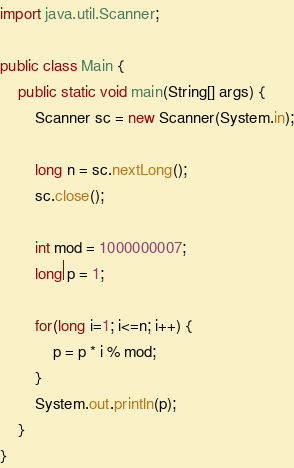<code> <loc_0><loc_0><loc_500><loc_500><_Java_>import java.util.Scanner;

public class Main {
    public static void main(String[] args) {
        Scanner sc = new Scanner(System.in);

        long n = sc.nextLong();
        sc.close();

        int mod = 1000000007;
        long p = 1;
        
        for(long i=1; i<=n; i++) {
            p = p * i % mod;
        }
        System.out.println(p);
    }
}
</code> 